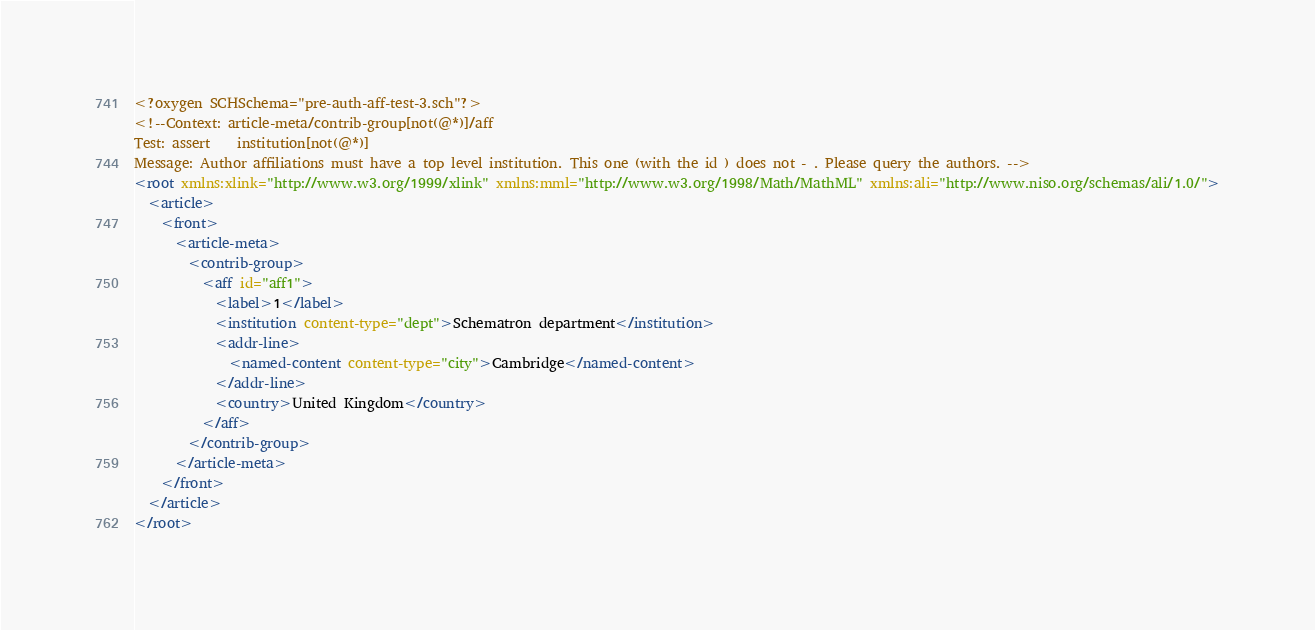Convert code to text. <code><loc_0><loc_0><loc_500><loc_500><_XML_><?oxygen SCHSchema="pre-auth-aff-test-3.sch"?>
<!--Context: article-meta/contrib-group[not(@*)]/aff
Test: assert    institution[not(@*)]
Message: Author affiliations must have a top level institution. This one (with the id ) does not - . Please query the authors. -->
<root xmlns:xlink="http://www.w3.org/1999/xlink" xmlns:mml="http://www.w3.org/1998/Math/MathML" xmlns:ali="http://www.niso.org/schemas/ali/1.0/">
  <article>
    <front>
      <article-meta>
        <contrib-group>
          <aff id="aff1">
            <label>1</label>
            <institution content-type="dept">Schematron department</institution>
            <addr-line>
              <named-content content-type="city">Cambridge</named-content>
            </addr-line>
            <country>United Kingdom</country>
          </aff>
        </contrib-group>
      </article-meta>
    </front>
  </article>
</root></code> 